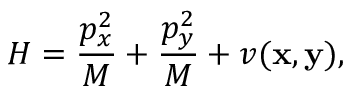<formula> <loc_0><loc_0><loc_500><loc_500>H = \frac { p _ { x } ^ { 2 } } { M } + \frac { p _ { y } ^ { 2 } } { M } + v ( { x } , { y } ) ,</formula> 